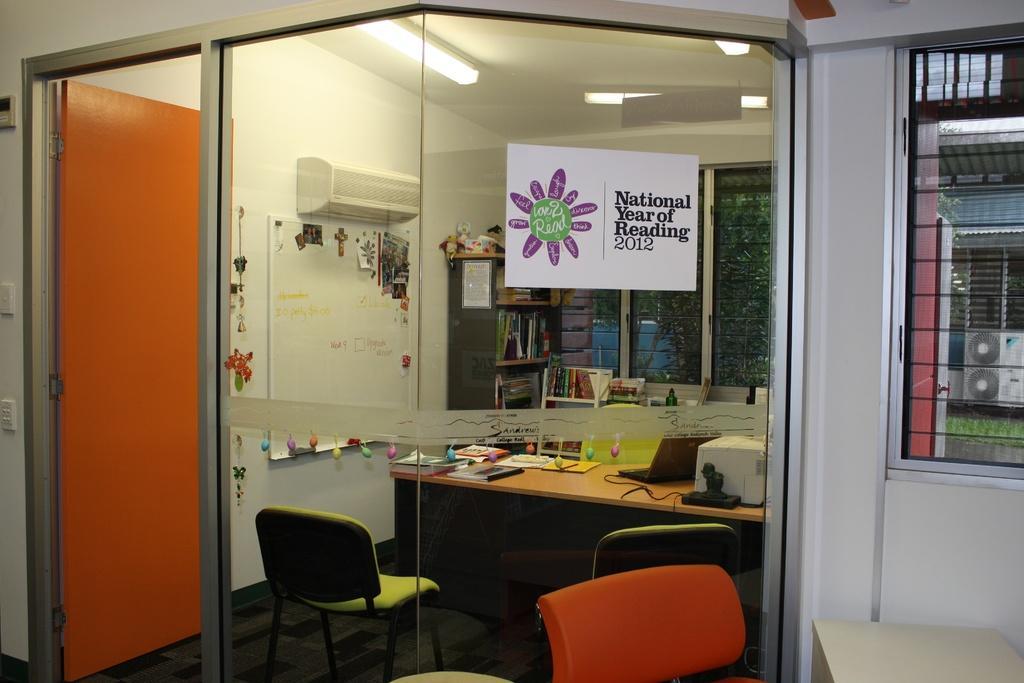Please provide a concise description of this image. This image is taken indoors. At the bottom of the image there is a floor. In the middle of the image there are three empty chairs and a table with many things on it. On the right side of the image there is a wall with a window and grills and there is a table. In the background there are a few walls with an air conditioner, a board with text on it, a door, a switchboard and windows. There is a cupboard with many books on it. At the top of the image there is a ceiling with lights. 